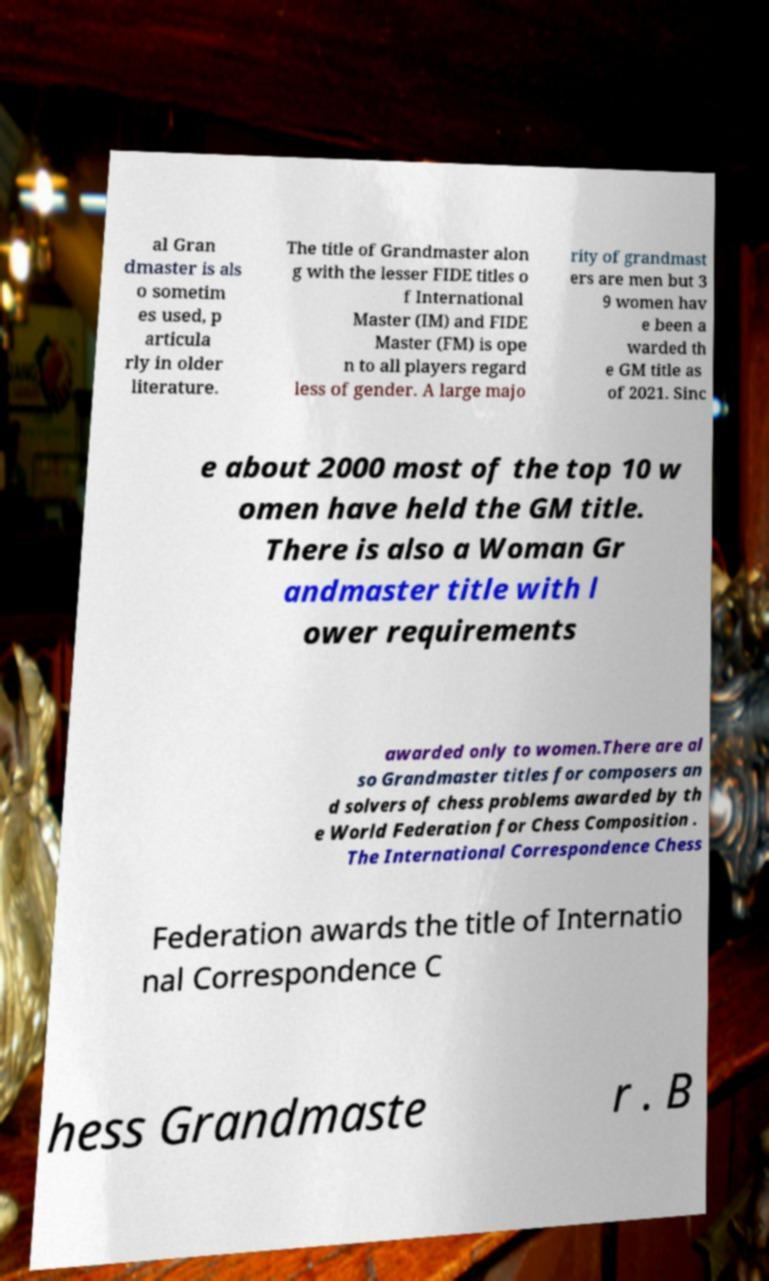There's text embedded in this image that I need extracted. Can you transcribe it verbatim? al Gran dmaster is als o sometim es used, p articula rly in older literature. The title of Grandmaster alon g with the lesser FIDE titles o f International Master (IM) and FIDE Master (FM) is ope n to all players regard less of gender. A large majo rity of grandmast ers are men but 3 9 women hav e been a warded th e GM title as of 2021. Sinc e about 2000 most of the top 10 w omen have held the GM title. There is also a Woman Gr andmaster title with l ower requirements awarded only to women.There are al so Grandmaster titles for composers an d solvers of chess problems awarded by th e World Federation for Chess Composition . The International Correspondence Chess Federation awards the title of Internatio nal Correspondence C hess Grandmaste r . B 